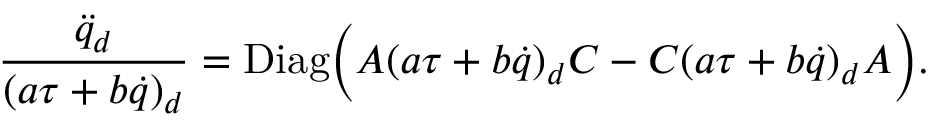Convert formula to latex. <formula><loc_0><loc_0><loc_500><loc_500>{ \frac { { \ddot { q } } _ { d } } { ( a \tau + b \dot { q } ) _ { d } } } = D i a g \left ( A ( a \tau + b \dot { q } ) _ { d } C - C ( a \tau + b \dot { q } ) _ { d } A \right ) .</formula> 